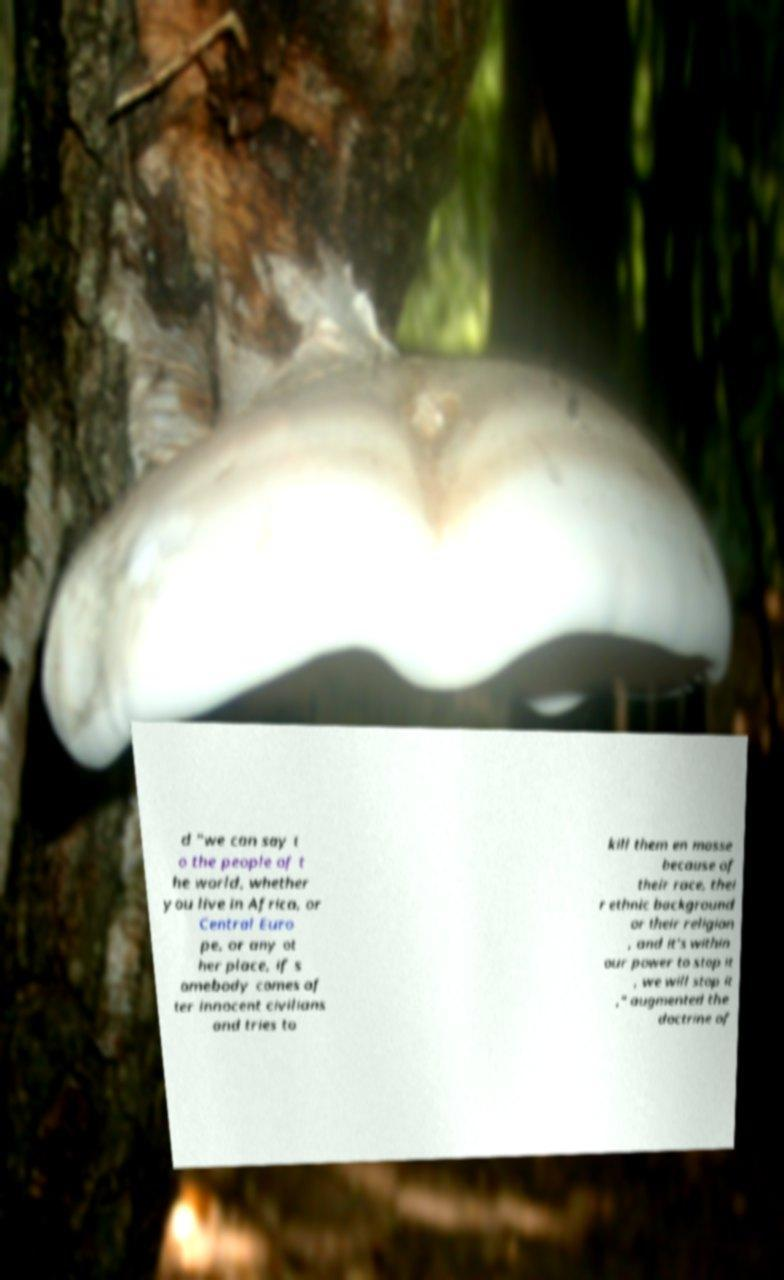Can you read and provide the text displayed in the image?This photo seems to have some interesting text. Can you extract and type it out for me? d "we can say t o the people of t he world, whether you live in Africa, or Central Euro pe, or any ot her place, if s omebody comes af ter innocent civilians and tries to kill them en masse because of their race, thei r ethnic background or their religion , and it's within our power to stop it , we will stop it ," augmented the doctrine of 